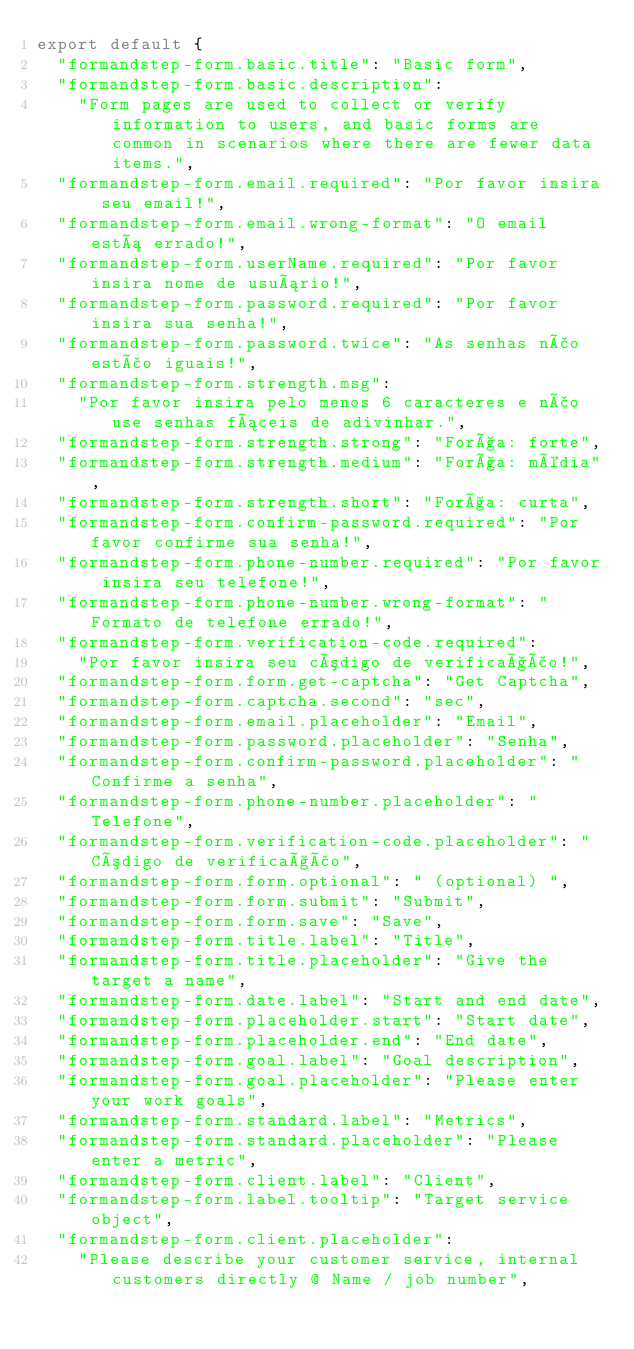<code> <loc_0><loc_0><loc_500><loc_500><_JavaScript_>export default {
  "formandstep-form.basic.title": "Basic form",
  "formandstep-form.basic.description":
    "Form pages are used to collect or verify information to users, and basic forms are common in scenarios where there are fewer data items.",
  "formandstep-form.email.required": "Por favor insira seu email!",
  "formandstep-form.email.wrong-format": "O email está errado!",
  "formandstep-form.userName.required": "Por favor insira nome de usuário!",
  "formandstep-form.password.required": "Por favor insira sua senha!",
  "formandstep-form.password.twice": "As senhas não estão iguais!",
  "formandstep-form.strength.msg":
    "Por favor insira pelo menos 6 caracteres e não use senhas fáceis de adivinhar.",
  "formandstep-form.strength.strong": "Força: forte",
  "formandstep-form.strength.medium": "Força: média",
  "formandstep-form.strength.short": "Força: curta",
  "formandstep-form.confirm-password.required": "Por favor confirme sua senha!",
  "formandstep-form.phone-number.required": "Por favor insira seu telefone!",
  "formandstep-form.phone-number.wrong-format": "Formato de telefone errado!",
  "formandstep-form.verification-code.required":
    "Por favor insira seu código de verificação!",
  "formandstep-form.form.get-captcha": "Get Captcha",
  "formandstep-form.captcha.second": "sec",
  "formandstep-form.email.placeholder": "Email",
  "formandstep-form.password.placeholder": "Senha",
  "formandstep-form.confirm-password.placeholder": "Confirme a senha",
  "formandstep-form.phone-number.placeholder": "Telefone",
  "formandstep-form.verification-code.placeholder": "Código de verificação",
  "formandstep-form.form.optional": " (optional) ",
  "formandstep-form.form.submit": "Submit",
  "formandstep-form.form.save": "Save",
  "formandstep-form.title.label": "Title",
  "formandstep-form.title.placeholder": "Give the target a name",
  "formandstep-form.date.label": "Start and end date",
  "formandstep-form.placeholder.start": "Start date",
  "formandstep-form.placeholder.end": "End date",
  "formandstep-form.goal.label": "Goal description",
  "formandstep-form.goal.placeholder": "Please enter your work goals",
  "formandstep-form.standard.label": "Metrics",
  "formandstep-form.standard.placeholder": "Please enter a metric",
  "formandstep-form.client.label": "Client",
  "formandstep-form.label.tooltip": "Target service object",
  "formandstep-form.client.placeholder":
    "Please describe your customer service, internal customers directly @ Name / job number",</code> 